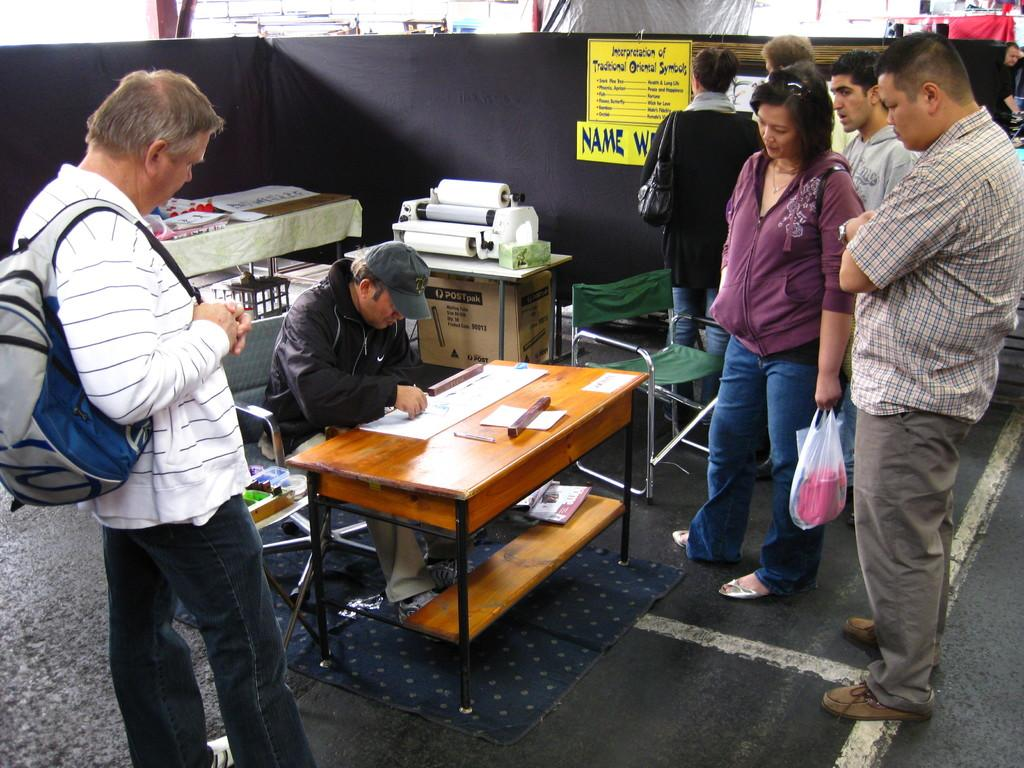What are the people in the image doing? The people in the image are standing and looking at the man seated on a chair. What is the man seated on the chair doing? The man is seated on a chair and working with a paper on a table. What is the man working with on the table? The man is working with a paper on the table. What type of string is being used by the people in the image? There is no string present in the image. What is the limit of the paper the man is working with in the image? The provided facts do not mention any limit on the paper the man is working with. 